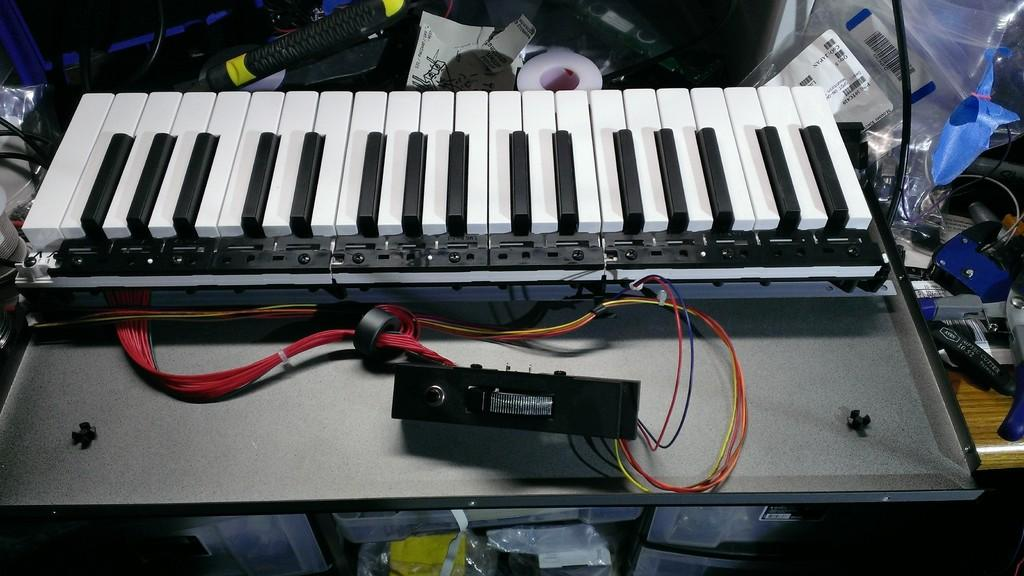What musical instrument is present in the image? There is a piano with a keyboard in the image. What else can be seen in the image besides the piano? Wires, tape, papers, plastic covers on a table, and boxes are visible in the image. What might the wires be connected to? The wires could be connected to the piano or other electronic devices in the image. What are the plastic covers on the table likely protecting? The plastic covers on the table are likely protecting the items underneath them from dust or damage. Are there any plants growing in the dirt in the image? There is no dirt or plants present in the image. 